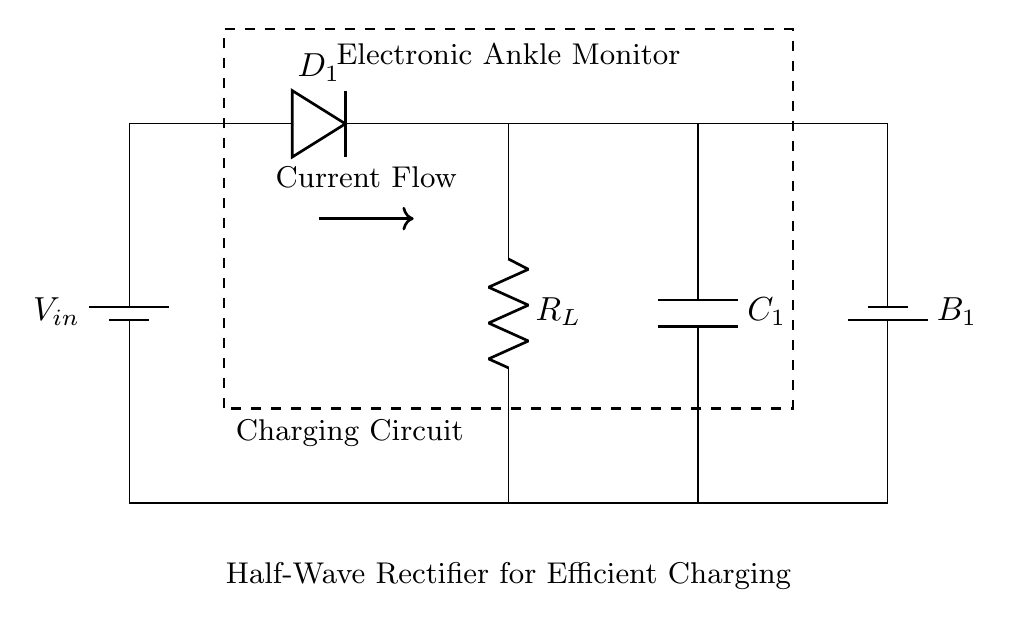What type of rectifier is shown in the circuit? The circuit diagram features a half-wave rectifier, indicated by the presence of a single diode that allows only one half of the AC waveform to pass through to the load resistor, effectively converting AC to DC.
Answer: Half-wave What is the role of the diode in this circuit? The diode in the circuit allows current to flow in one direction only, blocking the opposite half of the AC waveform. This action is fundamental for converting alternating current into direct current, making it essential for the charging process of the monitor's battery.
Answer: Current direction What is the function of the capacitor in this circuit? The capacitor smooths the output voltage by storing charge during the conduction phase and releasing it during the non-conduction phase of the rectifier cycle, helping to maintain a more constant voltage level for the load.
Answer: Voltage smoothing What is the purpose of the load resistor labeled as R_L? The load resistor R_L represents the electronic ankle monitor, as it consumes the power delivered by the rectified output to operate the device. The resistor is a critical part of the circuit that determines the current flow necessary for the monitor's functionality.
Answer: Power consumption How does the current flow direction change in this circuit? The current flows from the battery through the diode to the load (R_L) during the positive half-cycle of the AC input, while during the negative half-cycle, the diode blocks the current, preventing any reverse flow. This directionality is demonstrated by the one-way conductive nature of the diode.
Answer: One-way What is the significance of using a half-wave rectifier for charging? A half-wave rectifier is utilized for its simplicity and efficiency in applications where size and cost are constraints, such as in electronic ankle monitors. Although it is less efficient than full-wave rectifiers, it is adequate for low-power applications, providing effective battery charging with minimal components.
Answer: Cost-efficient 